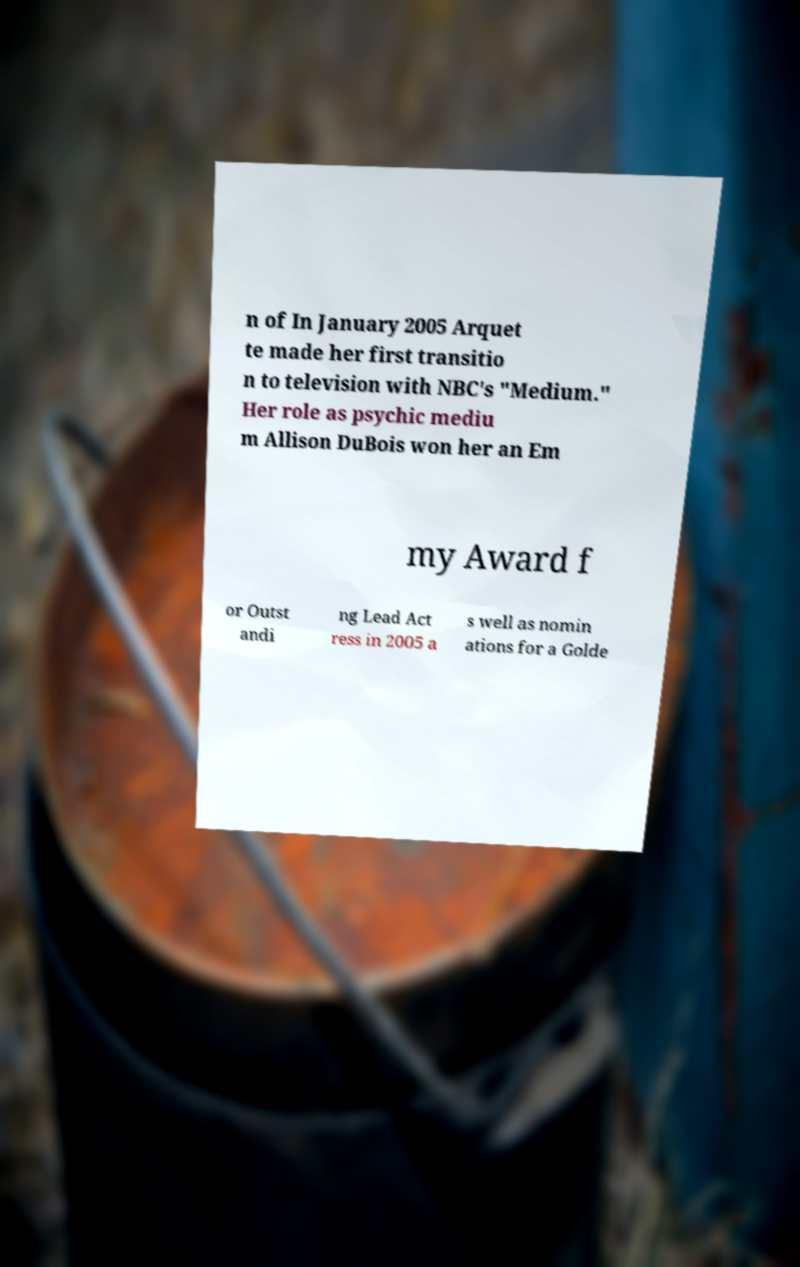Can you read and provide the text displayed in the image?This photo seems to have some interesting text. Can you extract and type it out for me? n of In January 2005 Arquet te made her first transitio n to television with NBC's "Medium." Her role as psychic mediu m Allison DuBois won her an Em my Award f or Outst andi ng Lead Act ress in 2005 a s well as nomin ations for a Golde 